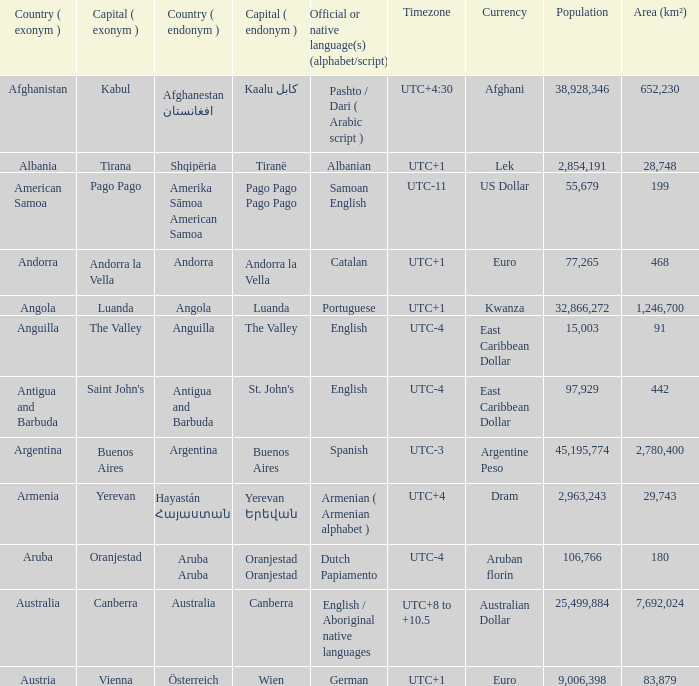Parse the full table. {'header': ['Country ( exonym )', 'Capital ( exonym )', 'Country ( endonym )', 'Capital ( endonym )', 'Official or native language(s) (alphabet/script)', 'Timezone', 'Currency', 'Population', 'Area (km²)'], 'rows': [['Afghanistan', 'Kabul', 'Afghanestan افغانستان', 'Kaalu كابل', 'Pashto / Dari ( Arabic script )', 'UTC+4:30', 'Afghani', '38,928,346', '652,230'], ['Albania', 'Tirana', 'Shqipëria', 'Tiranë', 'Albanian', 'UTC+1', 'Lek', '2,854,191', '28,748'], ['American Samoa', 'Pago Pago', 'Amerika Sāmoa American Samoa', 'Pago Pago Pago Pago', 'Samoan English', 'UTC-11', 'US Dollar', '55,679', '199'], ['Andorra', 'Andorra la Vella', 'Andorra', 'Andorra la Vella', 'Catalan', 'UTC+1', 'Euro', '77,265', '468'], ['Angola', 'Luanda', 'Angola', 'Luanda', 'Portuguese', 'UTC+1', 'Kwanza', '32,866,272', '1,246,700'], ['Anguilla', 'The Valley', 'Anguilla', 'The Valley', 'English', 'UTC-4', 'East Caribbean Dollar', '15,003', '91'], ['Antigua and Barbuda', "Saint John's", 'Antigua and Barbuda', "St. John's", 'English', 'UTC-4', 'East Caribbean Dollar', '97,929', '442'], ['Argentina', 'Buenos Aires', 'Argentina', 'Buenos Aires', 'Spanish', 'UTC-3', 'Argentine Peso', '45,195,774', '2,780,400'], ['Armenia', 'Yerevan', 'Hayastán Հայաստան', 'Yerevan Երեվան', 'Armenian ( Armenian alphabet )', 'UTC+4', 'Dram', '2,963,243', '29,743'], ['Aruba', 'Oranjestad', 'Aruba Aruba', 'Oranjestad Oranjestad', 'Dutch Papiamento', 'UTC-4', 'Aruban florin', '106,766', '180'], ['Australia', 'Canberra', 'Australia', 'Canberra', 'English / Aboriginal native languages', 'UTC+8 to +10.5', 'Australian Dollar', '25,499,884', '7,692,024'], ['Austria', 'Vienna', 'Österreich', 'Wien', 'German', 'UTC+1', 'Euro', '9,006,398', '83,879']]} What is the local name given to the capital of Anguilla? The Valley. 